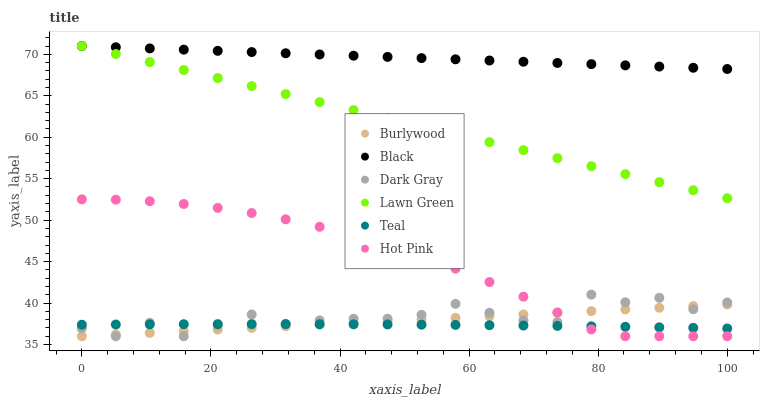Does Teal have the minimum area under the curve?
Answer yes or no. Yes. Does Black have the maximum area under the curve?
Answer yes or no. Yes. Does Burlywood have the minimum area under the curve?
Answer yes or no. No. Does Burlywood have the maximum area under the curve?
Answer yes or no. No. Is Lawn Green the smoothest?
Answer yes or no. Yes. Is Dark Gray the roughest?
Answer yes or no. Yes. Is Burlywood the smoothest?
Answer yes or no. No. Is Burlywood the roughest?
Answer yes or no. No. Does Burlywood have the lowest value?
Answer yes or no. Yes. Does Black have the lowest value?
Answer yes or no. No. Does Black have the highest value?
Answer yes or no. Yes. Does Burlywood have the highest value?
Answer yes or no. No. Is Burlywood less than Black?
Answer yes or no. Yes. Is Black greater than Teal?
Answer yes or no. Yes. Does Hot Pink intersect Burlywood?
Answer yes or no. Yes. Is Hot Pink less than Burlywood?
Answer yes or no. No. Is Hot Pink greater than Burlywood?
Answer yes or no. No. Does Burlywood intersect Black?
Answer yes or no. No. 